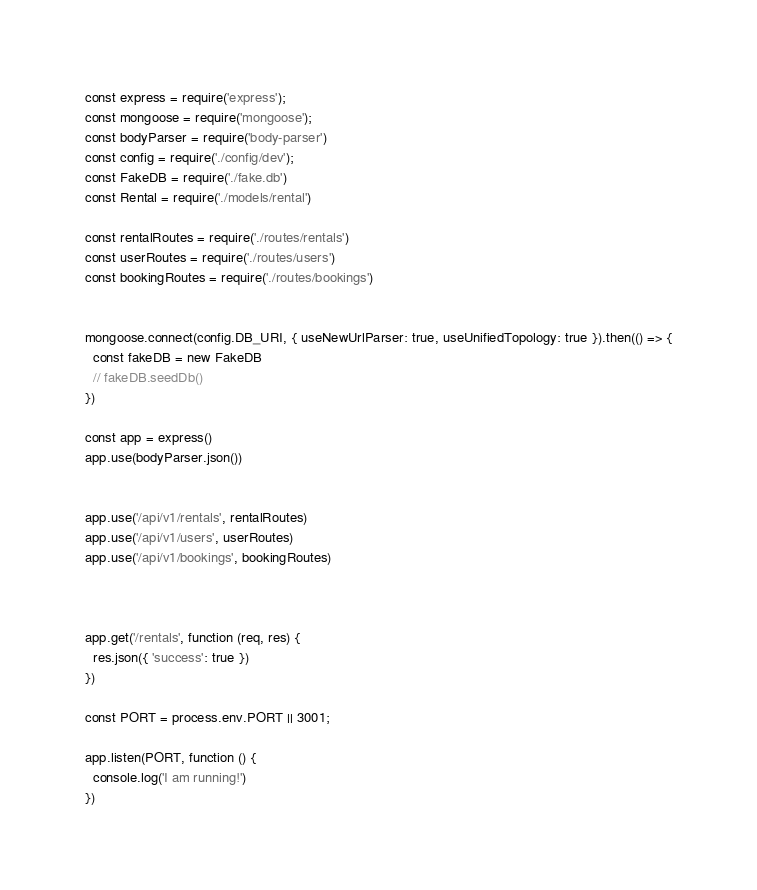<code> <loc_0><loc_0><loc_500><loc_500><_JavaScript_>const express = require('express');
const mongoose = require('mongoose');
const bodyParser = require('body-parser')
const config = require('./config/dev');
const FakeDB = require('./fake.db')
const Rental = require('./models/rental')

const rentalRoutes = require('./routes/rentals')
const userRoutes = require('./routes/users')
const bookingRoutes = require('./routes/bookings')


mongoose.connect(config.DB_URI, { useNewUrlParser: true, useUnifiedTopology: true }).then(() => {
  const fakeDB = new FakeDB
  // fakeDB.seedDb()
})

const app = express()
app.use(bodyParser.json())


app.use('/api/v1/rentals', rentalRoutes)
app.use('/api/v1/users', userRoutes)
app.use('/api/v1/bookings', bookingRoutes)



app.get('/rentals', function (req, res) {
  res.json({ 'success': true })
})

const PORT = process.env.PORT || 3001;

app.listen(PORT, function () {
  console.log('I am running!')
})

</code> 